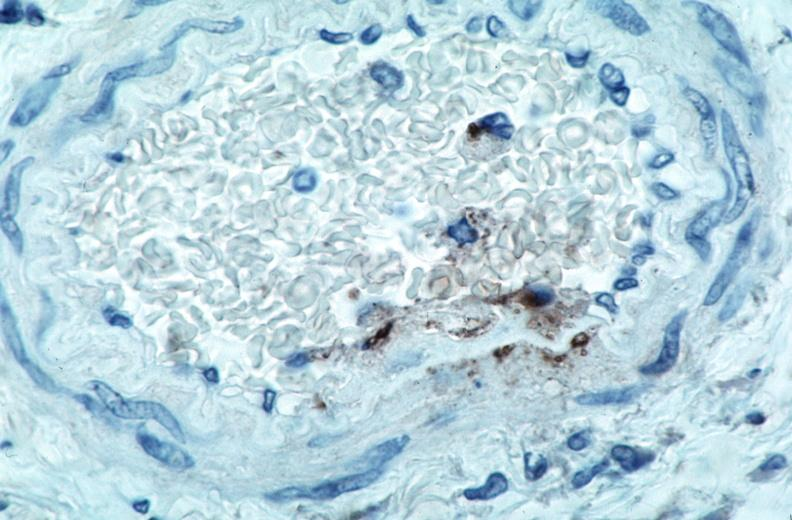what spotted fever, immunoperoxidase staining vessels for rickettsia rickettsii?
Answer the question using a single word or phrase. Rocky mountain 